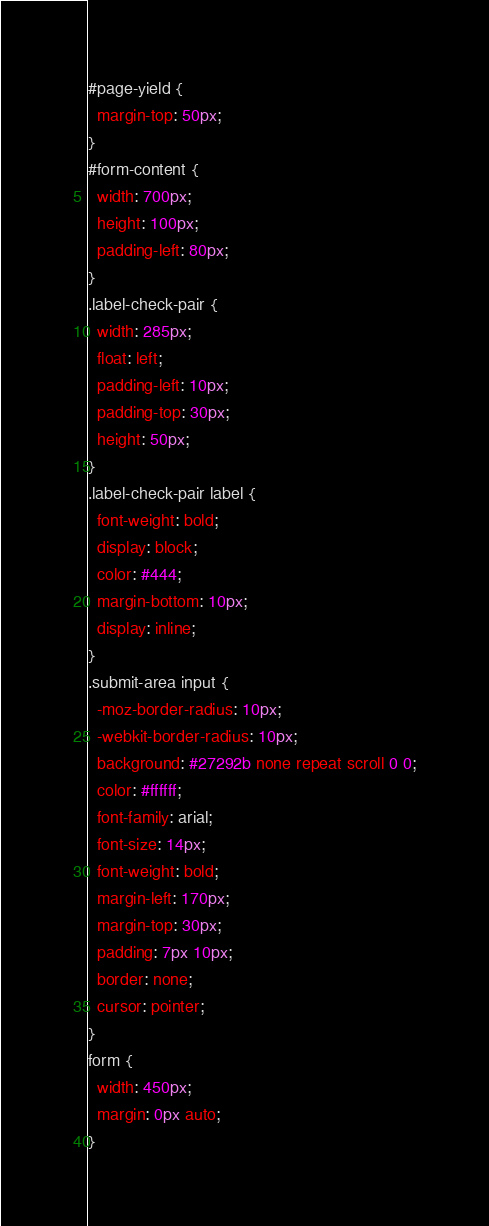<code> <loc_0><loc_0><loc_500><loc_500><_CSS_>#page-yield {
  margin-top: 50px;
}
#form-content {
  width: 700px;
  height: 100px;
  padding-left: 80px;
}
.label-check-pair {
  width: 285px;
  float: left;
  padding-left: 10px;
  padding-top: 30px;
  height: 50px;
}
.label-check-pair label {
  font-weight: bold;
  display: block;
  color: #444;
  margin-bottom: 10px;
  display: inline;
}
.submit-area input {
  -moz-border-radius: 10px;
  -webkit-border-radius: 10px;
  background: #27292b none repeat scroll 0 0;
  color: #ffffff;
  font-family: arial;
  font-size: 14px;
  font-weight: bold;
  margin-left: 170px;
  margin-top: 30px;
  padding: 7px 10px;
  border: none;
  cursor: pointer;
}
form {
  width: 450px;
  margin: 0px auto;
}
</code> 